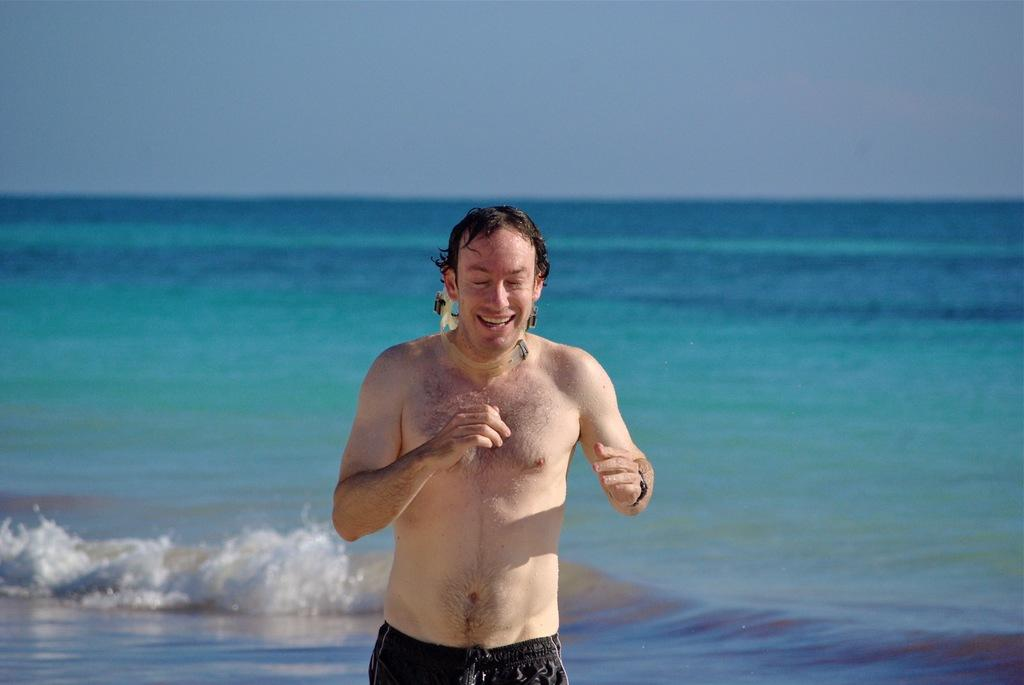What is the main subject of the image? There is a man standing in the image. What is the man wearing? The man is wearing a short. What is the man's facial expression? The man is smiling. What can be seen in the background of the image? There is an ocean and the sky visible in the background of the image. What type of pen is the man holding in the image? There is no pen present in the image; the man is not holding anything. 